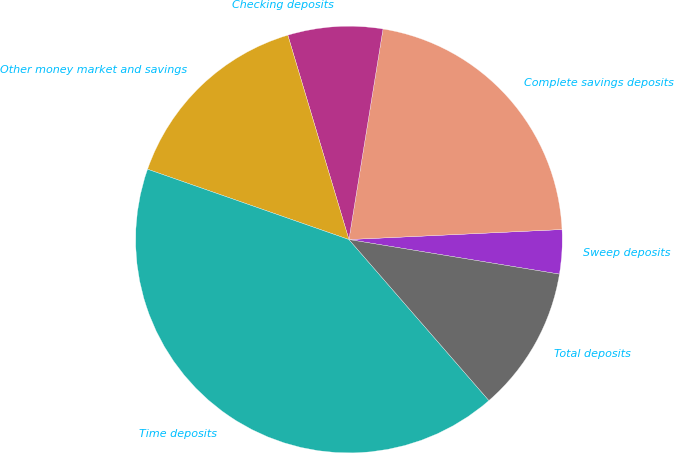Convert chart to OTSL. <chart><loc_0><loc_0><loc_500><loc_500><pie_chart><fcel>Sweep deposits<fcel>Complete savings deposits<fcel>Checking deposits<fcel>Other money market and savings<fcel>Time deposits<fcel>Total deposits<nl><fcel>3.34%<fcel>21.7%<fcel>7.18%<fcel>15.03%<fcel>41.74%<fcel>11.02%<nl></chart> 